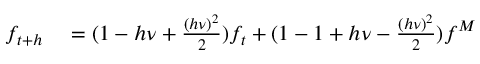<formula> <loc_0><loc_0><loc_500><loc_500>\begin{array} { r l } { f _ { t + h } } & = ( 1 - h \nu + \frac { ( h \nu ) ^ { 2 } } { 2 } ) f _ { t } + ( 1 - 1 + h \nu - \frac { ( h \nu ) ^ { 2 } } { 2 } ) f ^ { M } } \end{array}</formula> 